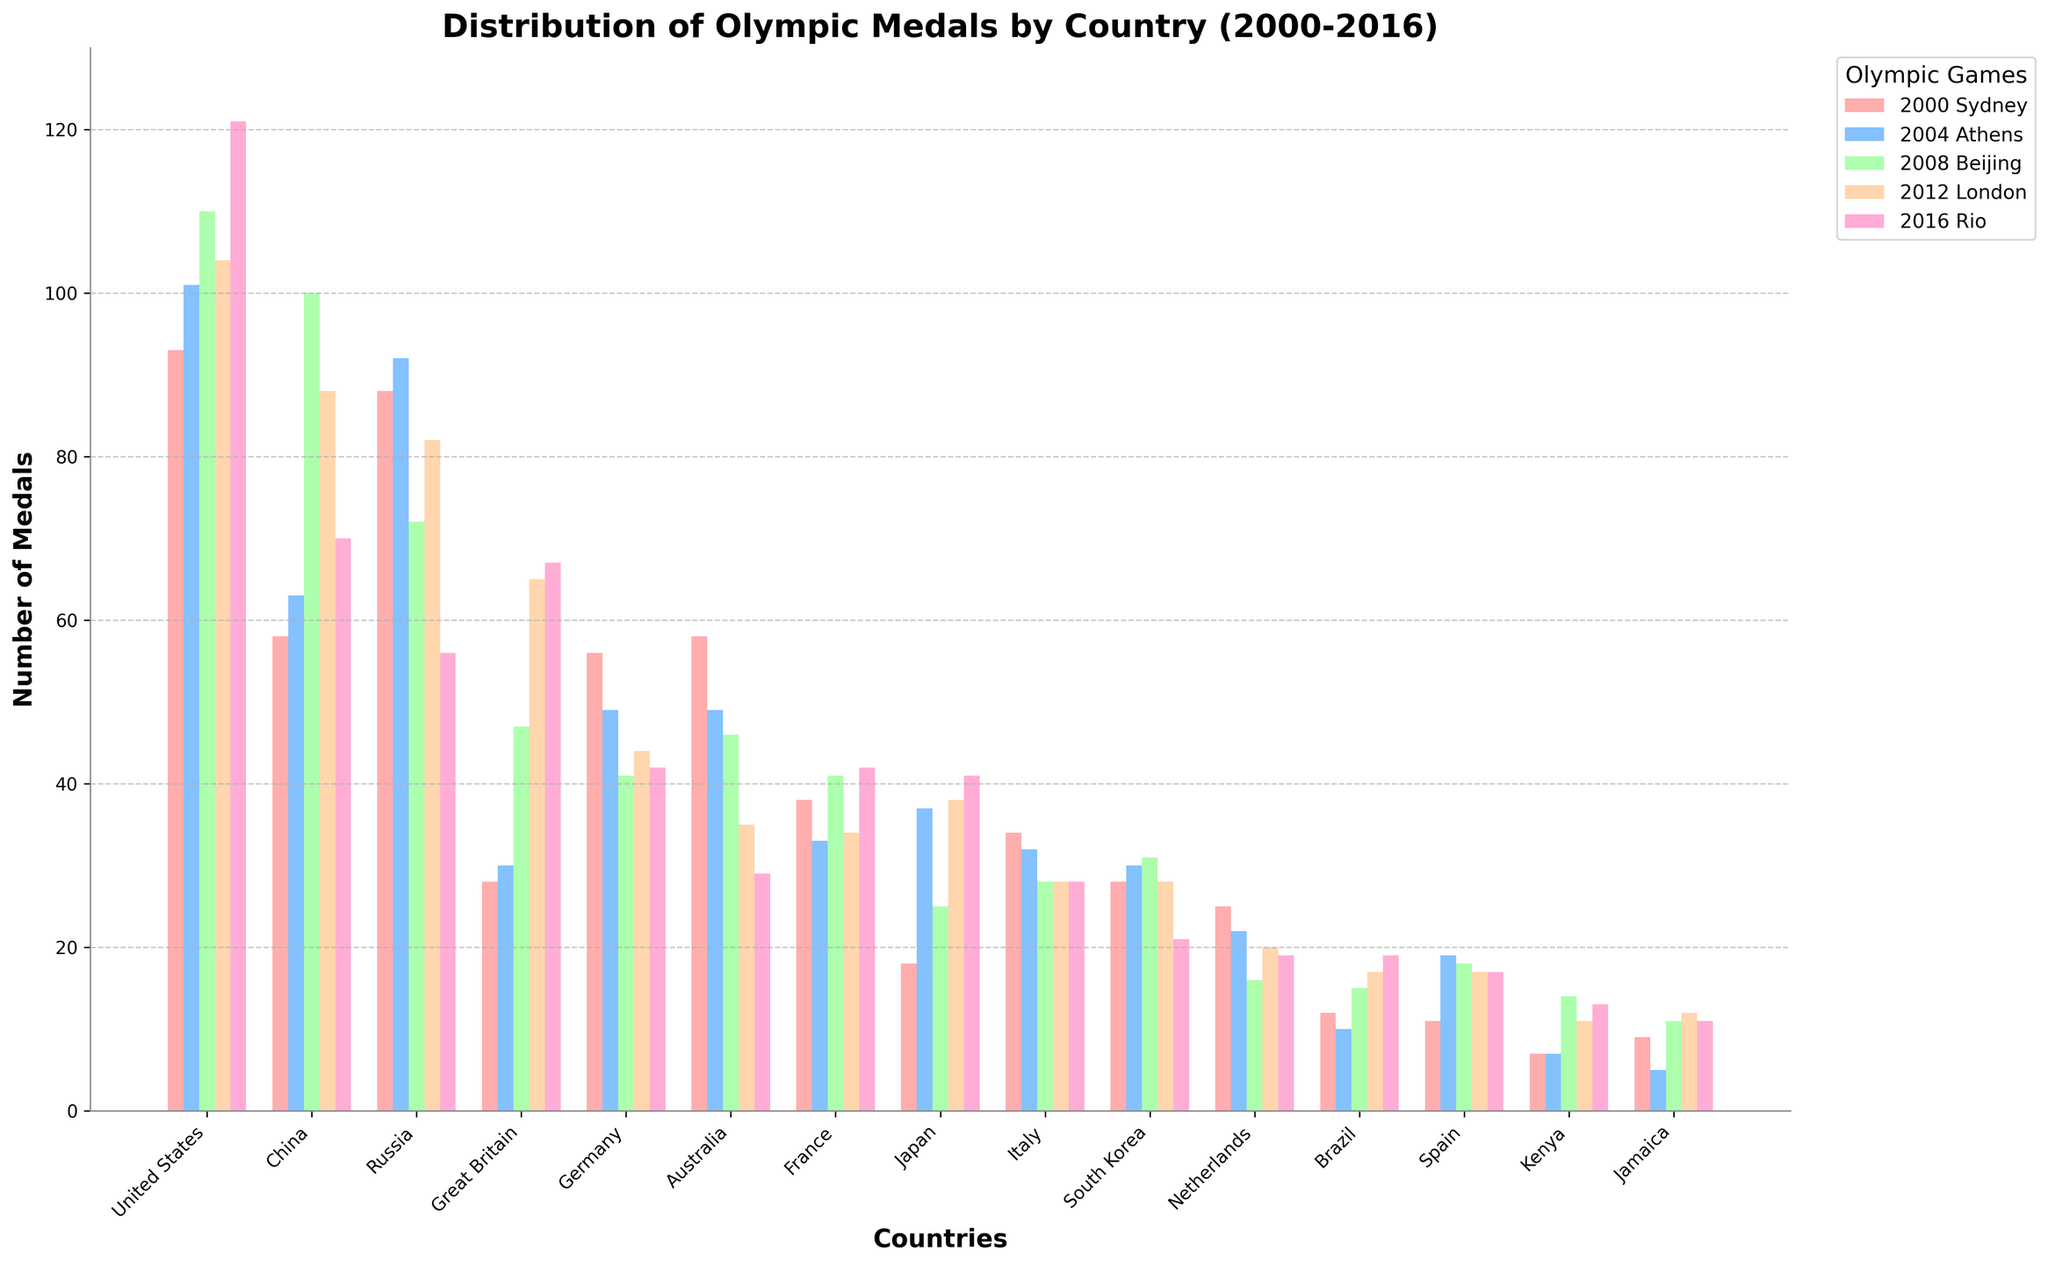Which country won the most medals in 2016 Rio? Look at each bar corresponding to the 2016 Rio Olympics. The highest bar represents the country with the most medals. The United States has the highest bar in this year.
Answer: United States Which two countries had the greatest increase in medal count from 2004 Athens to 2008 Beijing? First, compare the height of the bars for each country between 2004 Athens and 2008 Beijing. Calculate the increase for each country, and the two countries with the largest positive differences are China (increase of 37 medals) and Great Britain (increase of 17 medals).
Answer: China, Great Britain Which country had a consistent decrease in the total number of medals from 2000 to 2016? To find a consistent decrease, observe each country's bars across all five years and identify the one with a downward trend throughout. Australia’s total medals continuously decreased from 2000 Sydney (58) to 2016 Rio (29).
Answer: Australia What's the average number of medals won by Italy across all five Olympics? Sum the medal counts for Italy across all five Olympics: 34 + 32 + 28 + 28 + 28 = 150. Divide by the number of Olympic events (5): 150 / 5 = 30.
Answer: 30 Which country had the largest fluctuation in medal count between any two consecutive Olympics? For each country, calculate the absolute difference between consecutive years' medal counts, and identify the largest fluctuation. China had the largest fluctuation between 2008 Beijing (100) and 2012 London (88), with a difference of 12 medals.
Answer: China Which country had the smallest total medal count over the last five Summer Olympics? Add up the medal counts for each country over all five Olympics and identify the smallest sum. Jamaica had the smallest total with 9 + 5 + 11 + 12 + 11 = 48 medals.
Answer: Jamaica How many more medals did the United States win in 2016 Rio than in 2004 Athens? Subtract the United States medal count in 2004 Athens from the count in 2016 Rio: 121 - 101 = 20.
Answer: 20 What is the total number of medals won by South Korea in 2008 Beijing and 2012 London? Add the medal counts for South Korea in 2008 Beijing and 2012 London: 31 + 28 = 59.
Answer: 59 Comparing the colors of the bars, which two countries have bars of similar height for the 2000 Sydney Olympics? Visually inspect the bars for the 2000 Sydney Olympics, specifically looking at their height. France (38) and Japan (18) have bars that look quite similar in height.
Answer: France, Japan 